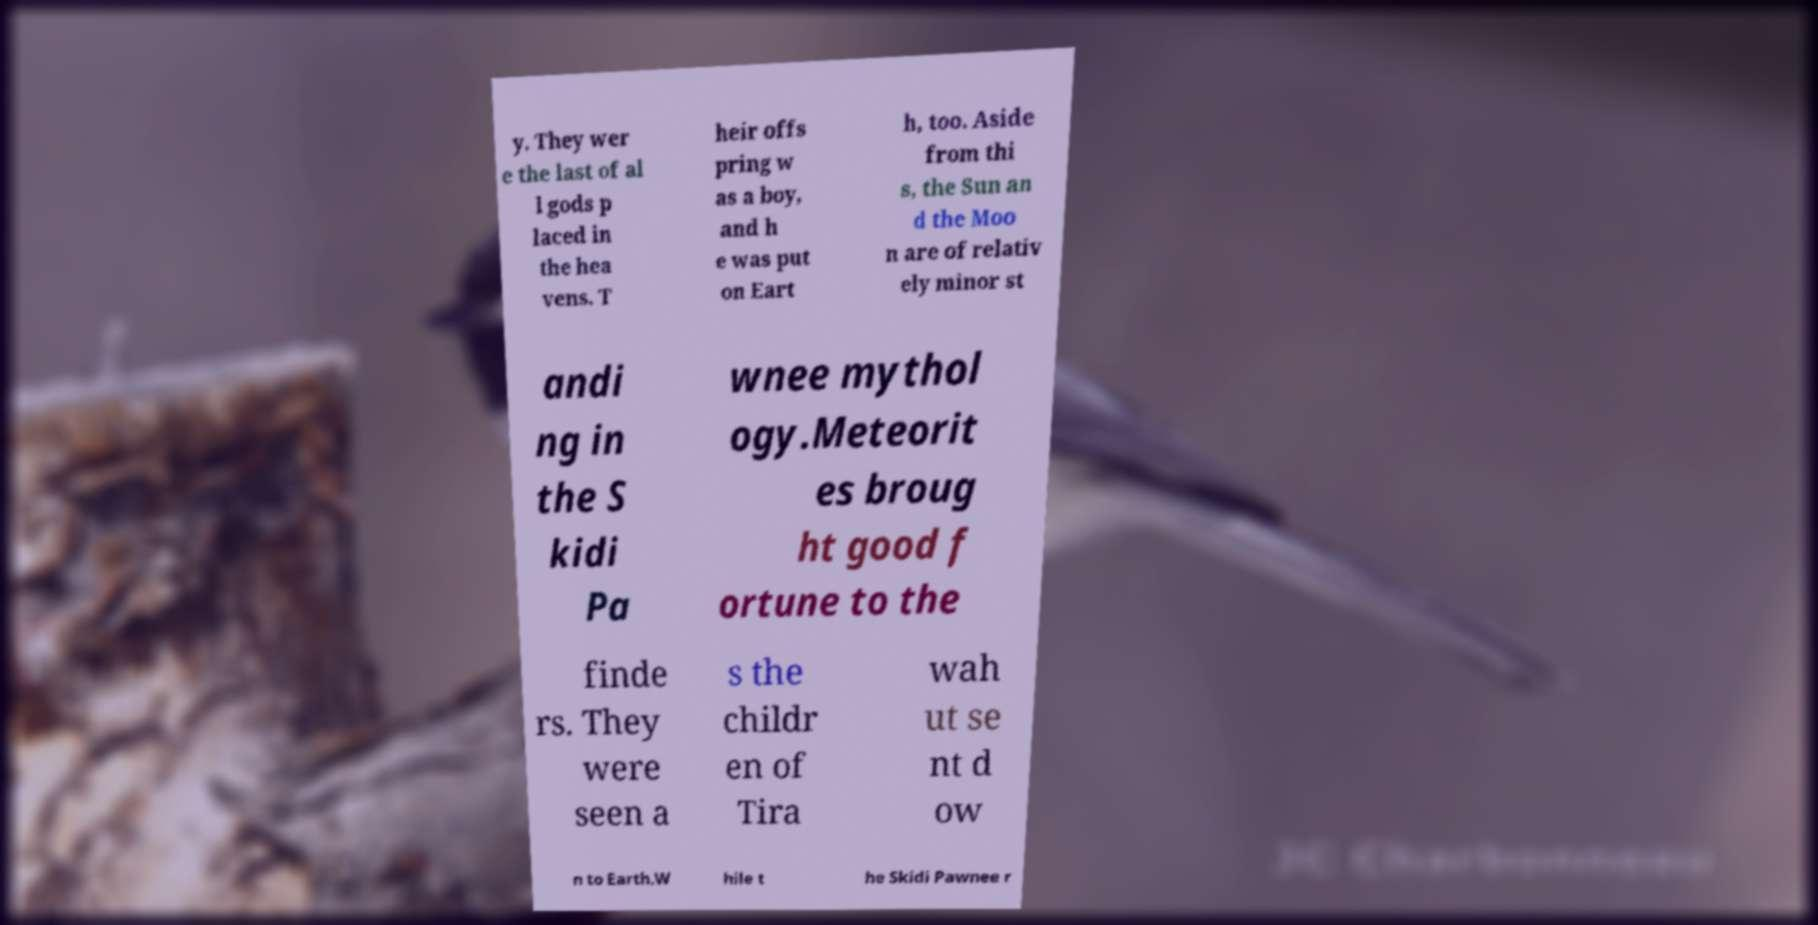For documentation purposes, I need the text within this image transcribed. Could you provide that? y. They wer e the last of al l gods p laced in the hea vens. T heir offs pring w as a boy, and h e was put on Eart h, too. Aside from thi s, the Sun an d the Moo n are of relativ ely minor st andi ng in the S kidi Pa wnee mythol ogy.Meteorit es broug ht good f ortune to the finde rs. They were seen a s the childr en of Tira wah ut se nt d ow n to Earth.W hile t he Skidi Pawnee r 